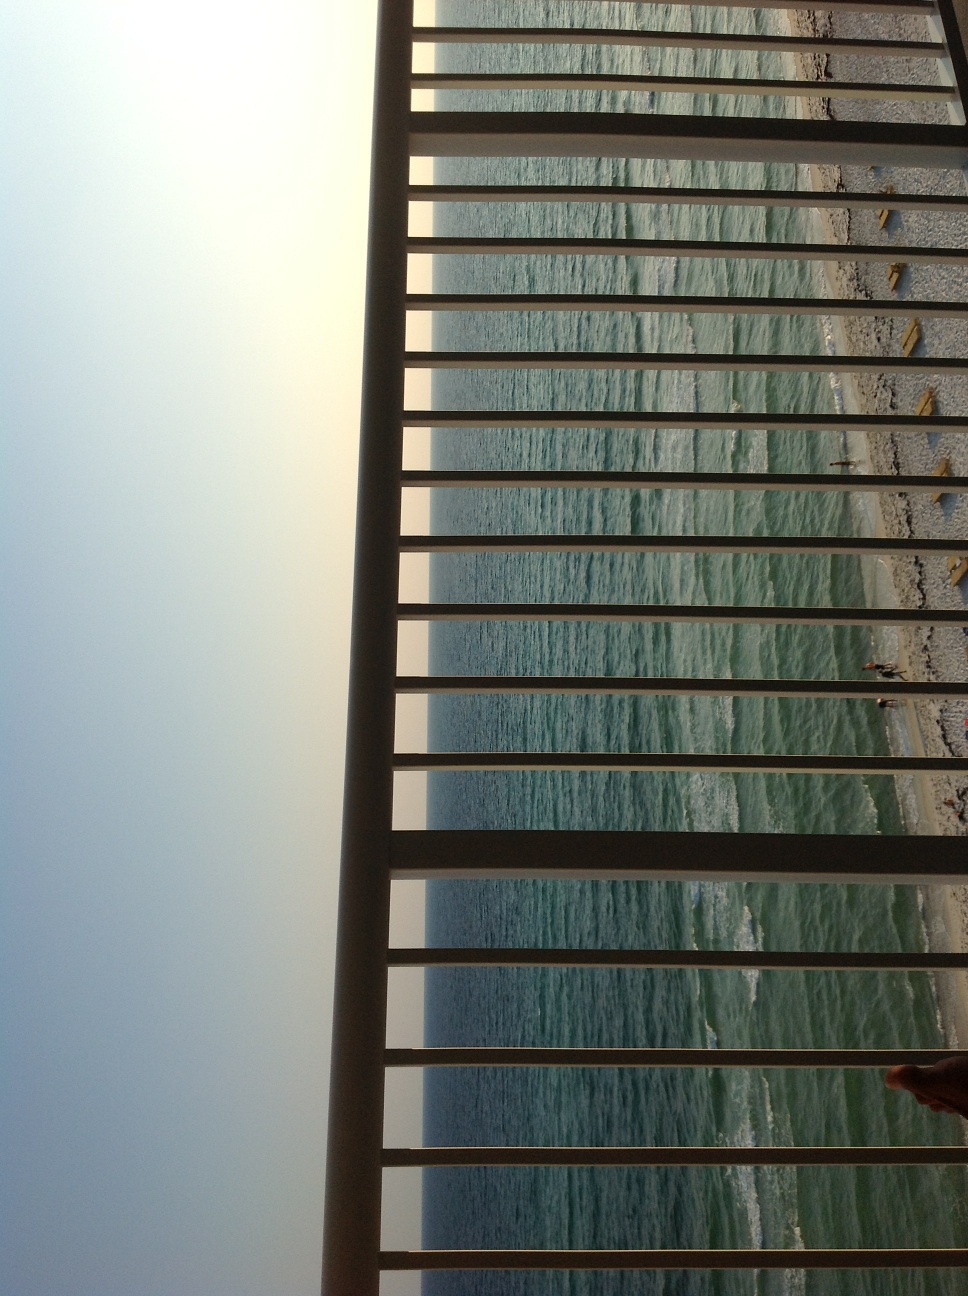Can you describe the time of day this photo was taken? The photo appears to be taken near sunset due to the warm but fading light casting soft shadows and a golden hue over the ocean, which usually indicates evening or late afternoon. 